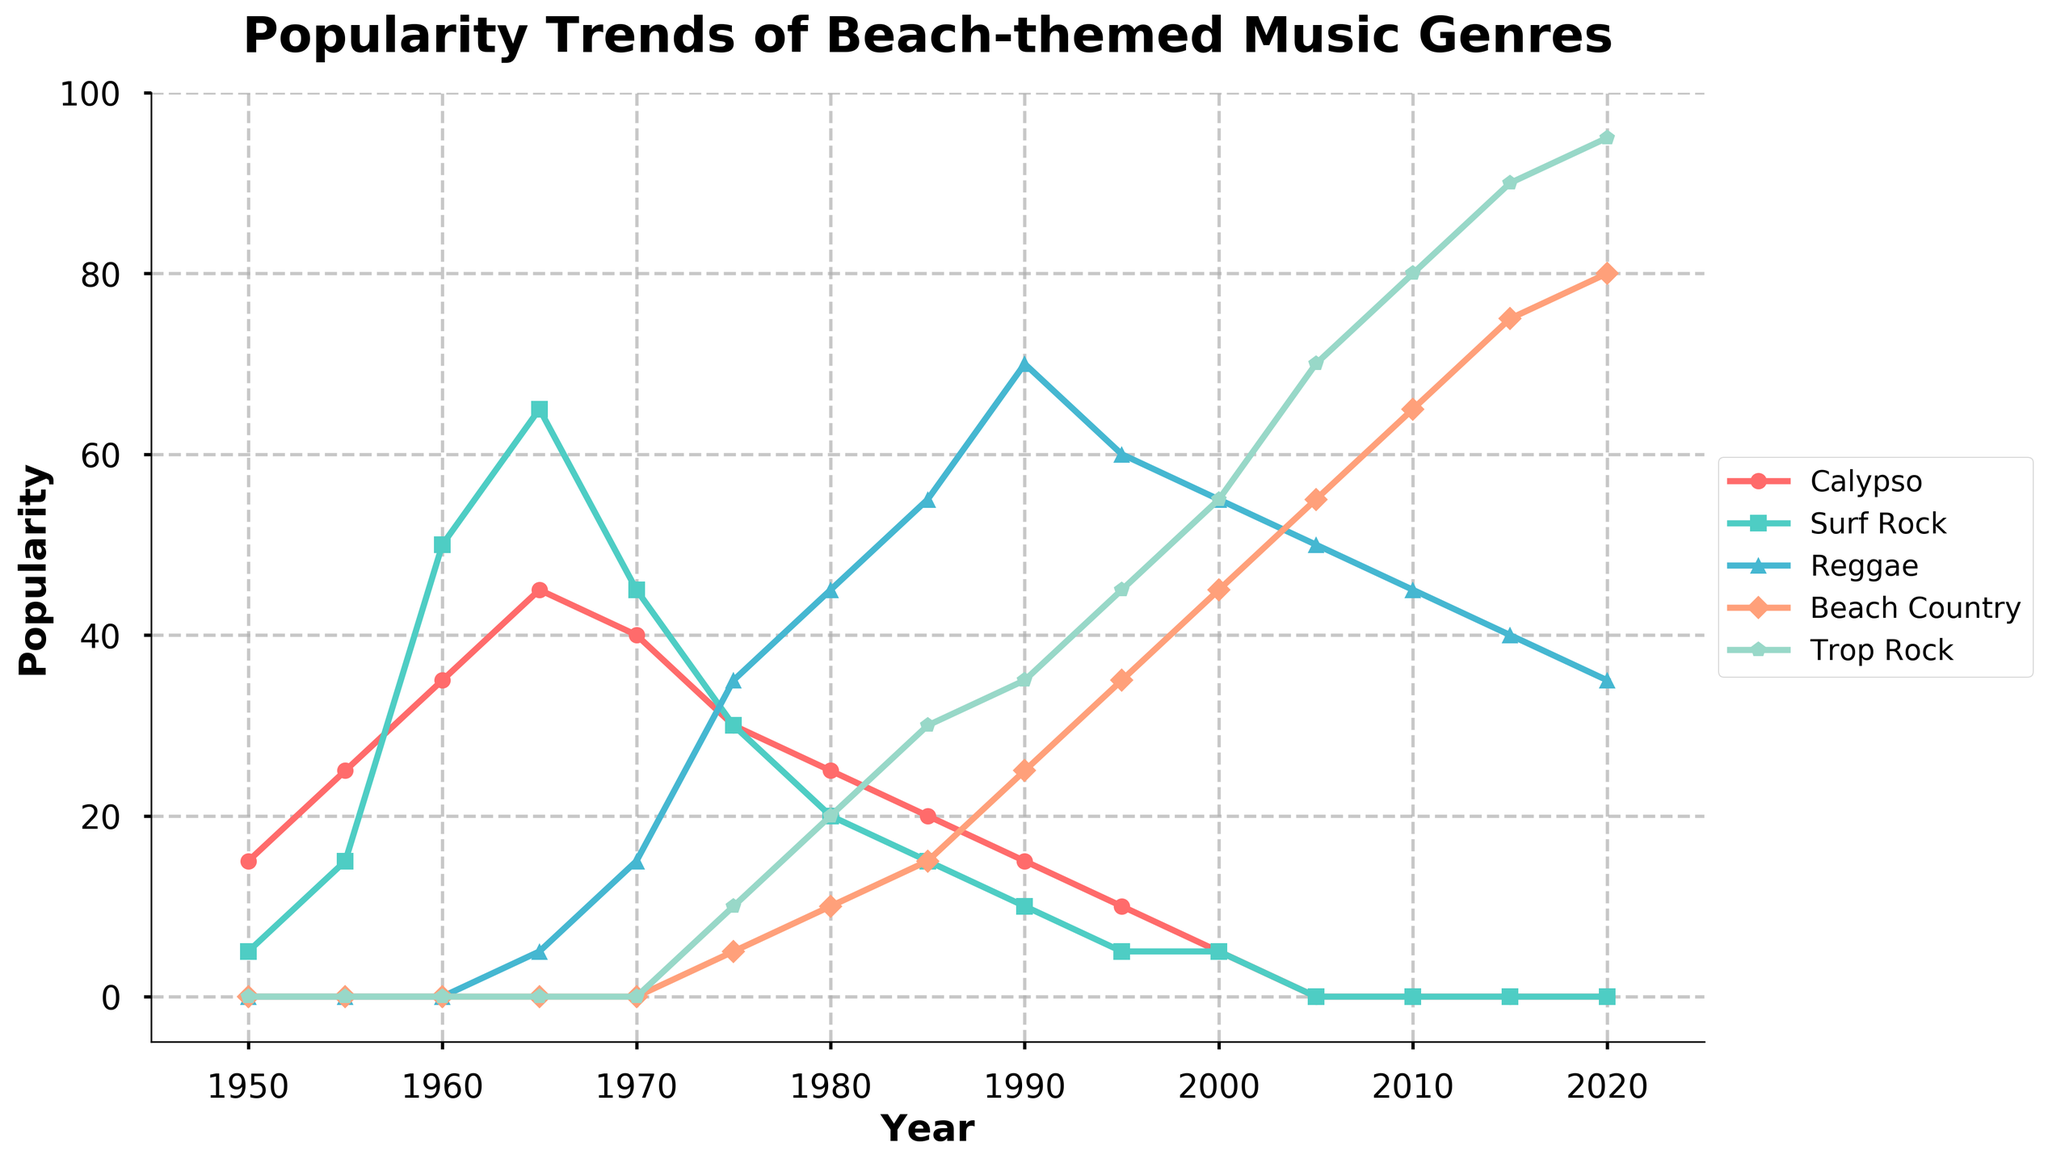What's the title of the figure? The title of the figure is written in large, bold font at the top and reads: "Popularity Trends of Beach-themed Music Genres".
Answer: Popularity Trends of Beach-themed Music Genres What is the y-axis representing? The y-axis label, written vertically on the left side of the plot, indicates that it represents "Popularity".
Answer: Popularity Which genre was the most popular in 1980? By looking at the y-axis values for the year 1980, Reggae has the highest point on the plot compared to other genres, reaching a popularity of 45.
Answer: Reggae When did Trop Rock reach its maximum popularity? By observing the teal-colored line representing Trop Rock, it reaches its highest point around the year 2020 with a popularity of 95.
Answer: 2020 Which two genres experienced a crossover in popularity around 1975? Around the year 1975, the lines for Reggae and Surf Rock intersect, indicating their popularity values cross over each other.
Answer: Reggae and Surf Rock What is the combined popularity of Calypso and Trop Rock in 1995? The popularity values for Calypso and Trop Rock in 1995 are 10 and 45 respectively. Summing them gives 10 + 45 = 55.
Answer: 55 Which genre declined consistently from 1950 to 2000? Observing the red line representing Calypso, it shows a declining trend from a high of 15 in 1950 to nearly 0 in 2000.
Answer: Calypso How long did it take for Surf Rock to drop to 0 in popularity? Surf Rock began with a popularity of 5 in 1950, peaked at around 65 in 1965, and dropped to 0 by 2005. This took approximately 55 years (2005 - 1950).
Answer: 55 years During which decade did Beach Country see its first noticeable rise in popularity? The yellow line representing Beach Country starts to rise noticeably around the 1970s, going from 5 in 1975 to 10 by 1980.
Answer: 1970s 